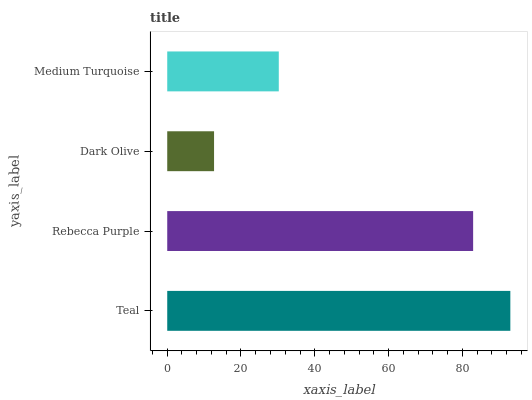Is Dark Olive the minimum?
Answer yes or no. Yes. Is Teal the maximum?
Answer yes or no. Yes. Is Rebecca Purple the minimum?
Answer yes or no. No. Is Rebecca Purple the maximum?
Answer yes or no. No. Is Teal greater than Rebecca Purple?
Answer yes or no. Yes. Is Rebecca Purple less than Teal?
Answer yes or no. Yes. Is Rebecca Purple greater than Teal?
Answer yes or no. No. Is Teal less than Rebecca Purple?
Answer yes or no. No. Is Rebecca Purple the high median?
Answer yes or no. Yes. Is Medium Turquoise the low median?
Answer yes or no. Yes. Is Medium Turquoise the high median?
Answer yes or no. No. Is Teal the low median?
Answer yes or no. No. 